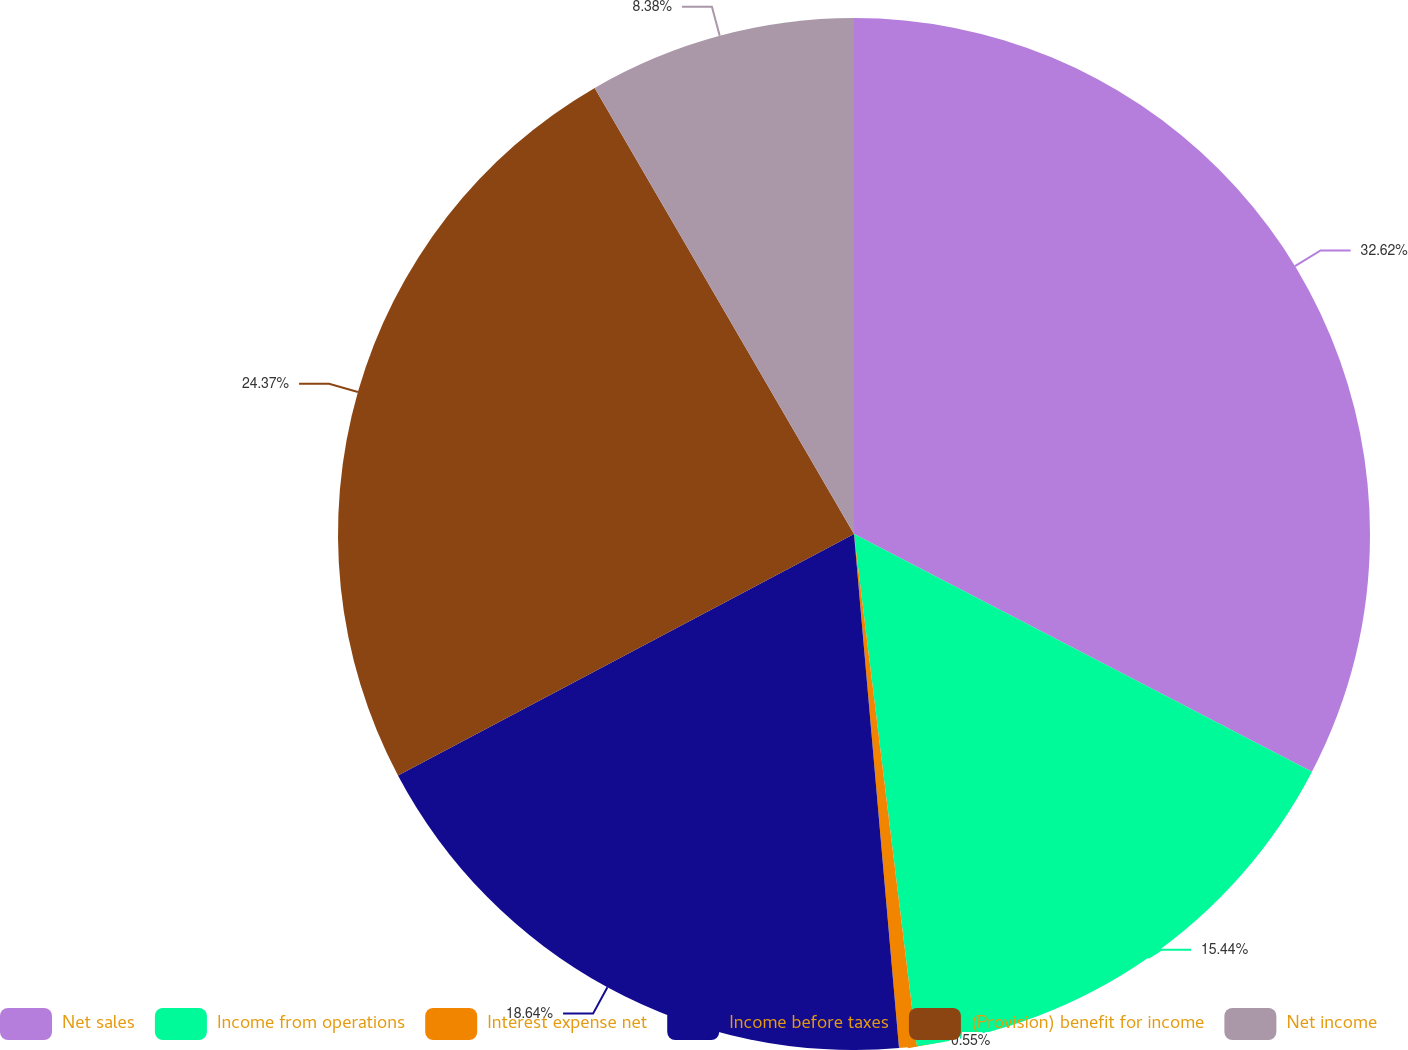Convert chart to OTSL. <chart><loc_0><loc_0><loc_500><loc_500><pie_chart><fcel>Net sales<fcel>Income from operations<fcel>Interest expense net<fcel>Income before taxes<fcel>(Provision) benefit for income<fcel>Net income<nl><fcel>32.62%<fcel>15.44%<fcel>0.55%<fcel>18.64%<fcel>24.37%<fcel>8.38%<nl></chart> 